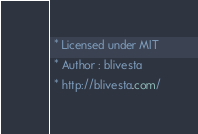<code> <loc_0><loc_0><loc_500><loc_500><_CSS_> * Licensed under MIT
 * Author : blivesta
 * http://blivesta.com/</code> 